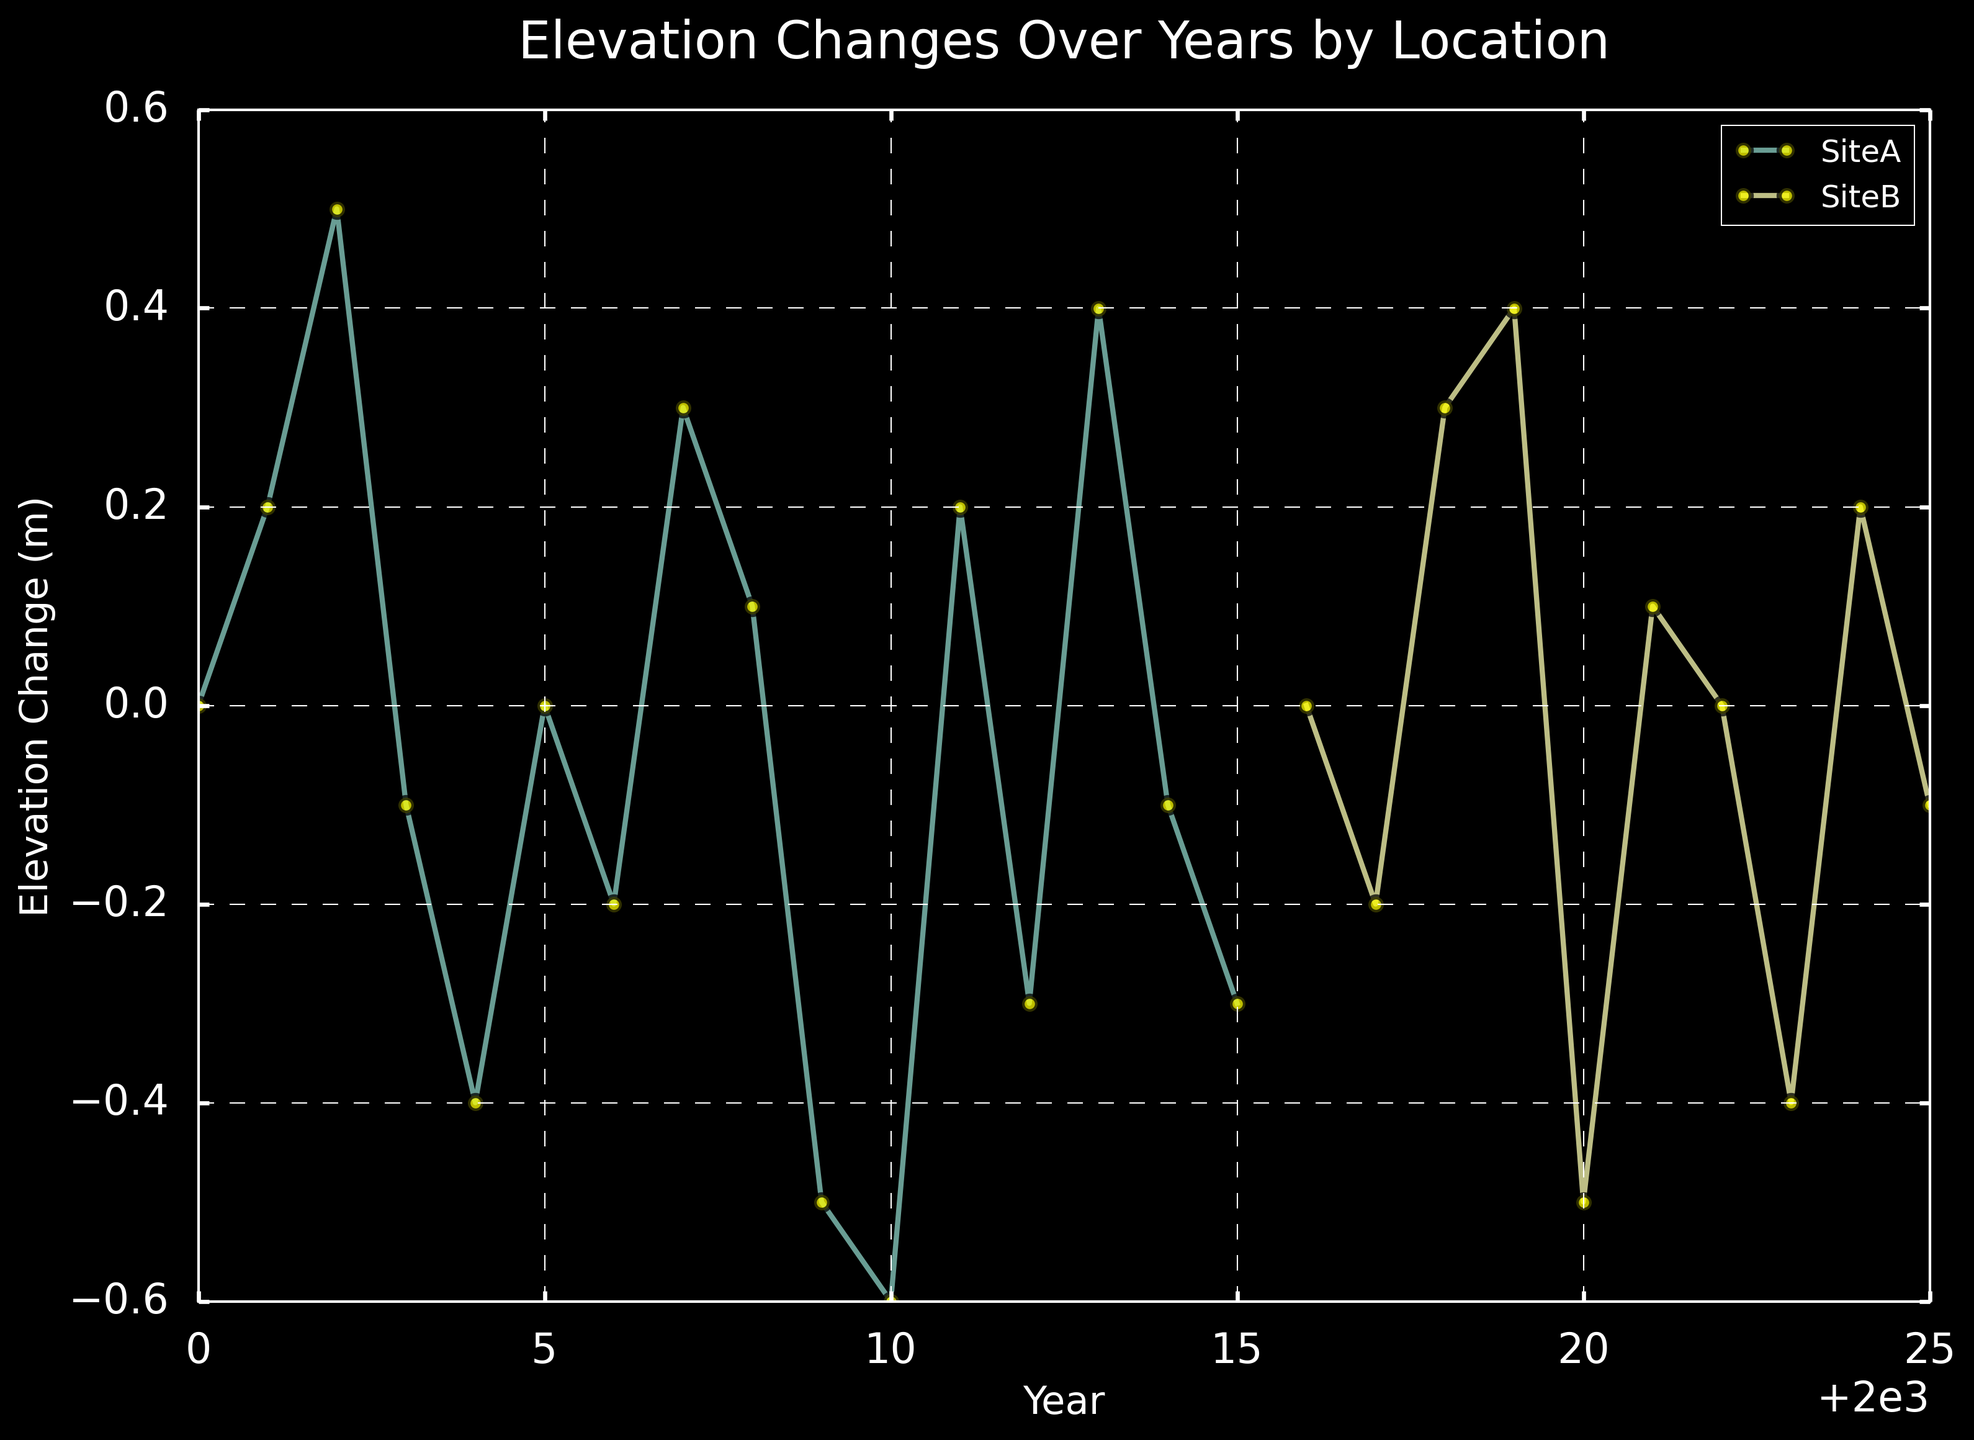What is the trend of elevation change at SiteA from 2000 to 2005? Look at the line representing SiteA from 2000 to 2005. Observe if it is increasing, decreasing, or stable.
Answer: Decreasing During which year did SiteA experience the largest negative change in elevation? Identify the year where the line for SiteA dips the lowest below the zero line. In this case, it is 2010.
Answer: 2010 Compare the elevation changes at SiteA and SiteB in 2018. Which site had a higher elevation change? Look at the data points for both SiteA and SiteB in 2018, compare their y-axis values. Since SiteA data stops at 2015, only SiteB is plotted in 2018 with a value of 0.3.
Answer: SiteB What is the average elevation change for SiteA from 2000 to 2015? Sum the elevation changes from 2000 to 2015 for SiteA, then divide by the number of years (16). The values are: 0.0, 0.2, 0.5, -0.1, -0.4, 0.0, -0.2, 0.3, 0.1, -0.5, -0.6, 0.2, -0.3, 0.4, -0.1, -0.3; summing them gives -0.3 and dividing by 16 gives -0.01875.
Answer: -0.01875 Between SiteA and SiteB, which location shows more oscillatory behavior in elevation changes? Look at the frequency and amplitude of changes between positive and negative values for both SiteA and SiteB. SiteA has more frequent shifts between positive and negative changes compared to SiteB.
Answer: SiteA In what year did SiteA and SiteB both have zero elevation change? Look for points where both SiteA and SiteB lines intersect the zero line. SiteA in 2000 and 2005, SiteB in 2016 and 2022.
Answer: 2000, 2005, 2016, 2022 What is the combined elevation change for SiteB from 2020 to 2025? Sum the elevation changes from 2020 to 2025 for SiteB. Values are: -0.5, 0.1, 0.0, -0.4, 0.2, -0.1. Adding these gives: -0.7.
Answer: -0.7 Which location experienced the first positive elevation change after 2010? Find the first positive elevation change data point for both locations post-2010. SiteA shows positive change in 2011 (0.2).
Answer: SiteA When did SiteB experience its maximum elevation change, and what was the value? Look for the highest point on the SiteB line. It occurs in 2019 with a value of 0.4.
Answer: 2019, 0.4 Did either SiteA or SiteB experience a net positive elevation change over the entire period shown in the figure? Sum all elevation changes for SiteA and for SiteB separately. If any sum is positive, then that site had a net positive change. SiteA sum: 0.0, SiteB sum: -0.7; both show net negative.
Answer: No 